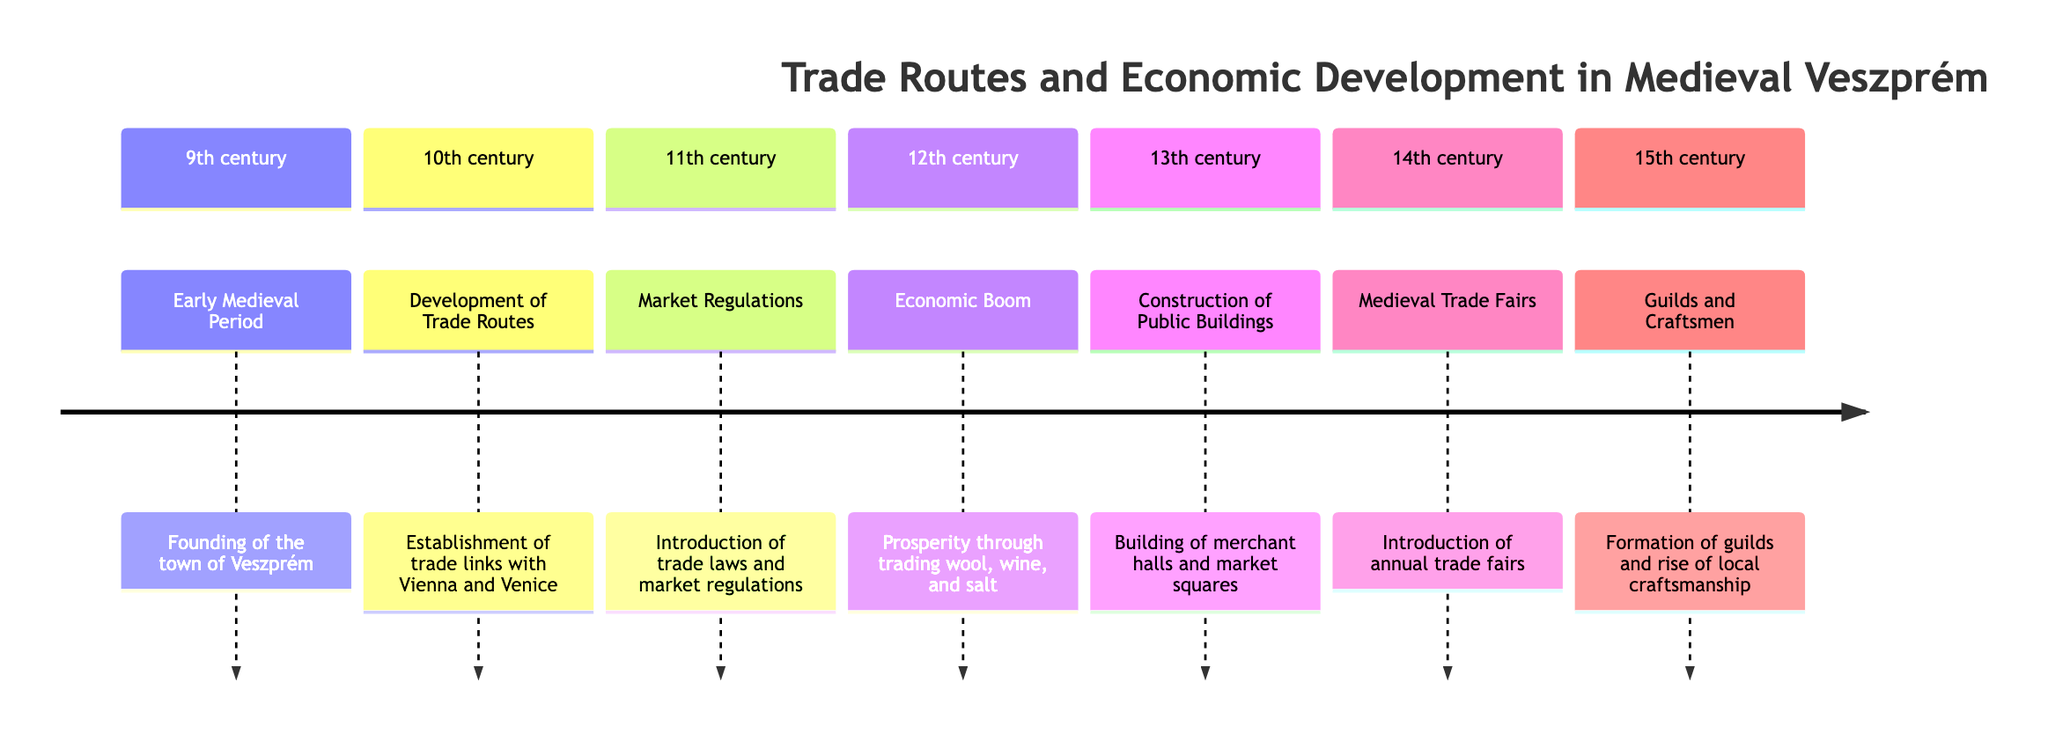What is the first event in the timeline? The first event listed is under the 9th century, which is the founding of the town of Veszprém.
Answer: Founding of the town of Veszprém Which century saw the establishment of trade links with Vienna and Venice? The establishment of trade links occurred in the 10th century, as indicated in the diagram.
Answer: 10th century What major economic activity was highlighted in the 12th century? The 12th century focuses on prosperity through trading wool, wine, and salt as significant economic activities.
Answer: Trading wool, wine, and salt What significant structures were built in the 13th century? The diagram specifies that merchant halls and market squares were constructed in the 13th century.
Answer: Merchant halls and market squares Which century introduced annual trade fairs? The introduction of annual trade fairs is noted for the 14th century in the diagram.
Answer: 14th century How did the formation of guilds and craftsmen relate to the local economy? The formation of guilds and the rise of local craftsmanship contributed to the economy in the 15th century. These two events are closely linked as guilds supported craftsmen in their trades.
Answer: Local craftsmanship What does the timeline suggest about the progression of economic activity over the centuries? The diagram illustrates a clear progression of economic activity, starting from the founding of the town, developing trade routes, and culminating in the formation of guilds, showing how Veszprém evolved economically over time.
Answer: Clear progression of economic activity How many distinct events are recorded in the diagram? Counting the events listed across all centuries, there are a total of seven distinct events recorded in the timeline.
Answer: Seven events 